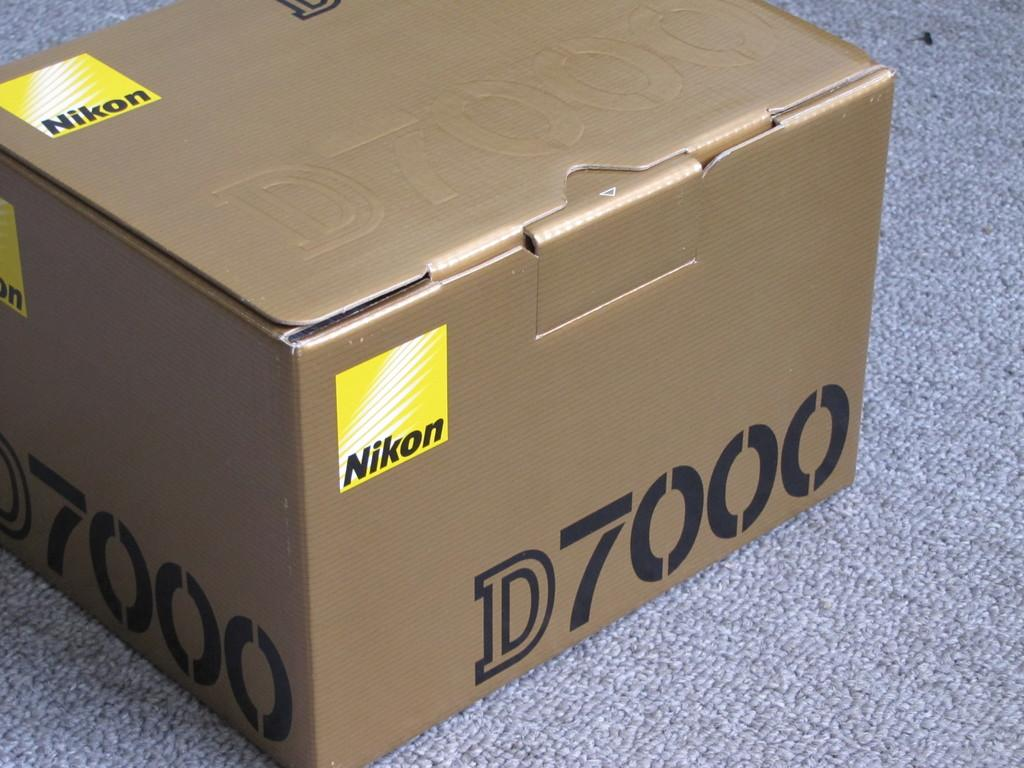Provide a one-sentence caption for the provided image. Nikon D7000 is labeled on this sealed, cardboard box. 